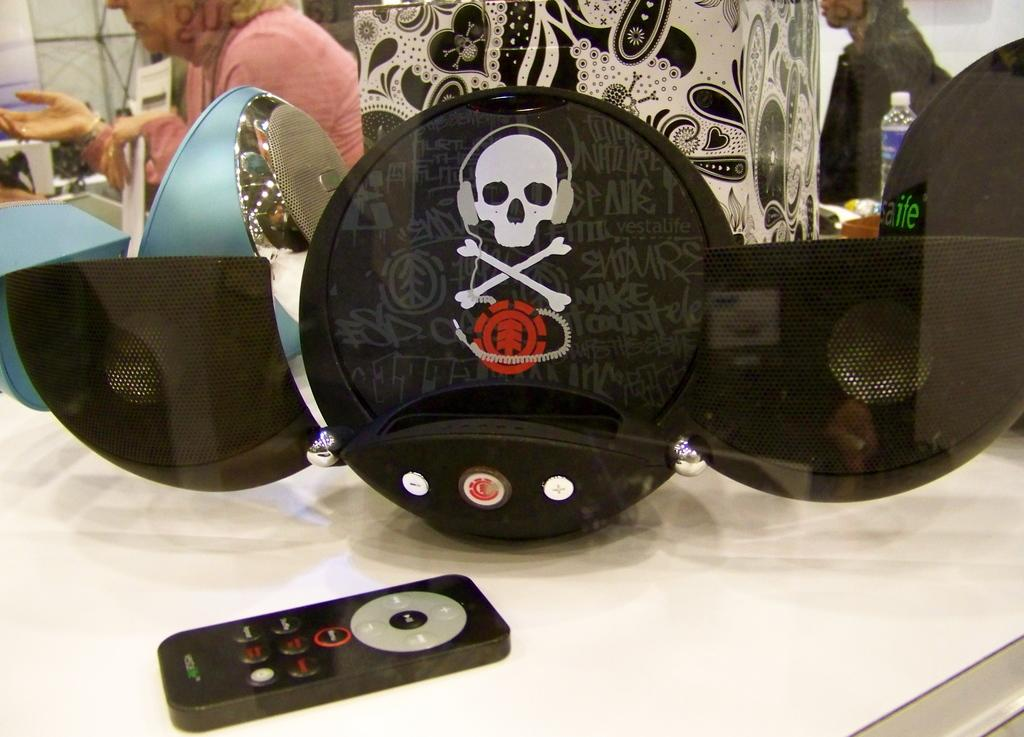What electronic device is present in the image? There is a remote in the image. What type of object can be used for carrying items? There is a bag in the image. What device is used for amplifying sound? There is a speaker in the image. What surface can be seen in the image with multiple objects on it? There are objects on a table in the image. How many people can be seen in the background of the image? There are two persons visible in the background of the image. What type of insects can be seen crawling on the remote in the image? There are no insects, including ants, visible on the remote in the image. What dental feature can be seen on the speaker in the image? There are no teeth present in the image, as it features a remote, bag, speaker, table, and two persons in the background. 